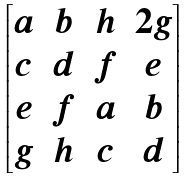<formula> <loc_0><loc_0><loc_500><loc_500>\begin{bmatrix} a & b & h & 2 g \\ c & d & f & e \\ e & f & a & b \\ g & h & c & d \end{bmatrix}</formula> 